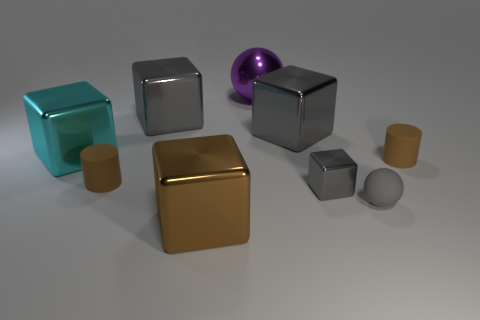How many brown cylinders must be subtracted to get 1 brown cylinders? 1 Subtract all yellow cylinders. How many gray blocks are left? 3 Subtract all big brown shiny blocks. How many blocks are left? 4 Subtract all cyan cubes. How many cubes are left? 4 Subtract all yellow cubes. Subtract all yellow spheres. How many cubes are left? 5 Add 1 tiny cubes. How many objects exist? 10 Subtract all cubes. How many objects are left? 4 Subtract all brown metallic balls. Subtract all brown rubber things. How many objects are left? 7 Add 8 brown shiny things. How many brown shiny things are left? 9 Add 2 large brown shiny things. How many large brown shiny things exist? 3 